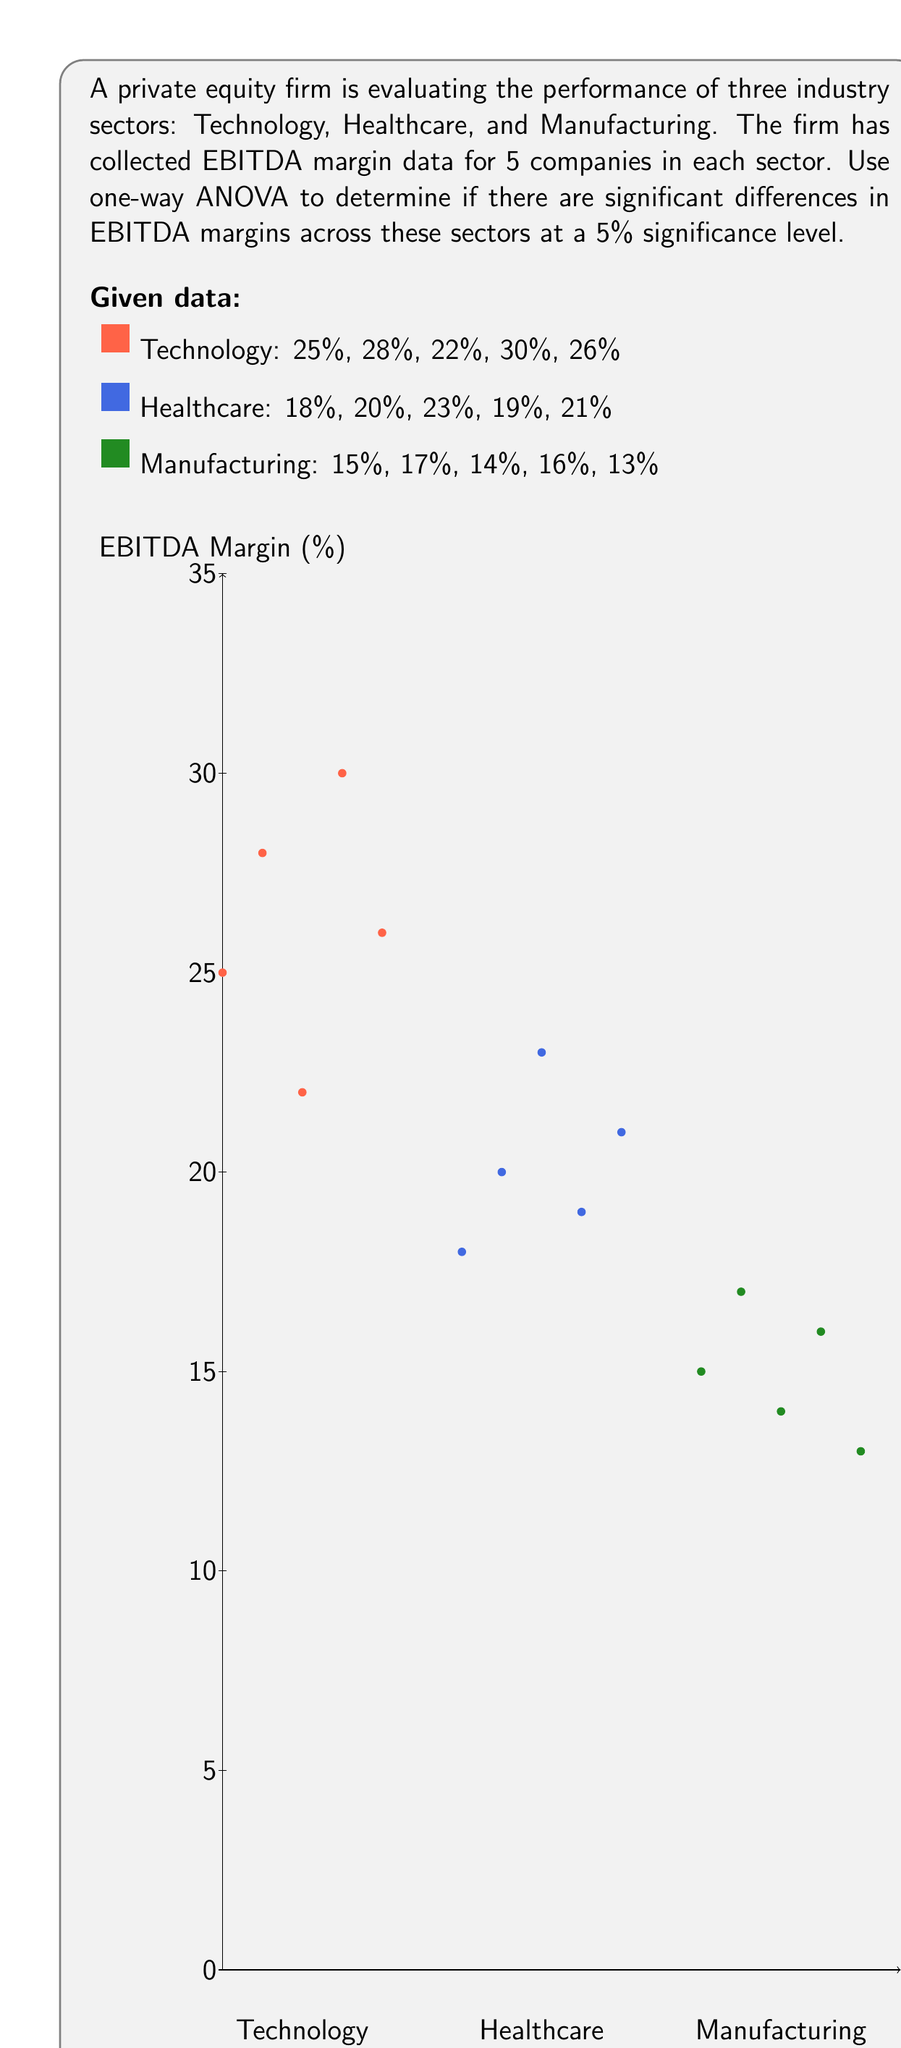Give your solution to this math problem. To perform a one-way ANOVA, we'll follow these steps:

1. Calculate the mean for each group and the overall mean:
   Technology mean: $\bar{x}_T = \frac{25 + 28 + 22 + 30 + 26}{5} = 26.2$
   Healthcare mean: $\bar{x}_H = \frac{18 + 20 + 23 + 19 + 21}{5} = 20.2$
   Manufacturing mean: $\bar{x}_M = \frac{15 + 17 + 14 + 16 + 13}{5} = 15$
   Overall mean: $\bar{x} = \frac{26.2 + 20.2 + 15}{3} = 20.47$

2. Calculate the Sum of Squares Between groups (SSB):
   $SSB = \sum_{i=1}^{k} n_i(\bar{x}_i - \bar{x})^2$
   where $k$ is the number of groups and $n_i$ is the number of observations in each group.
   
   $SSB = 5(26.2 - 20.47)^2 + 5(20.2 - 20.47)^2 + 5(15 - 20.47)^2 = 390.13$

3. Calculate the Sum of Squares Within groups (SSW):
   $SSW = \sum_{i=1}^{k} \sum_{j=1}^{n_i} (x_{ij} - \bar{x}_i)^2$
   
   Technology: $(25-26.2)^2 + (28-26.2)^2 + (22-26.2)^2 + (30-26.2)^2 + (26-26.2)^2 = 44.8$
   Healthcare: $(18-20.2)^2 + (20-20.2)^2 + (23-20.2)^2 + (19-20.2)^2 + (21-20.2)^2 = 18.8$
   Manufacturing: $(15-15)^2 + (17-15)^2 + (14-15)^2 + (16-15)^2 + (13-15)^2 = 12$
   
   $SSW = 44.8 + 18.8 + 12 = 75.6$

4. Calculate the degrees of freedom:
   $df_{between} = k - 1 = 3 - 1 = 2$
   $df_{within} = N - k = 15 - 3 = 12$
   where $N$ is the total number of observations.

5. Calculate the Mean Square Between (MSB) and Mean Square Within (MSW):
   $MSB = \frac{SSB}{df_{between}} = \frac{390.13}{2} = 195.065$
   $MSW = \frac{SSW}{df_{within}} = \frac{75.6}{12} = 6.3$

6. Calculate the F-statistic:
   $F = \frac{MSB}{MSW} = \frac{195.065}{6.3} = 30.96$

7. Find the critical F-value:
   For $\alpha = 0.05$, $df_{between} = 2$, and $df_{within} = 12$, the critical F-value is approximately 3.89.

8. Compare the F-statistic to the critical F-value:
   Since $30.96 > 3.89$, we reject the null hypothesis.
Answer: Reject null hypothesis; significant differences exist in EBITDA margins across sectors (F = 30.96, p < 0.05). 